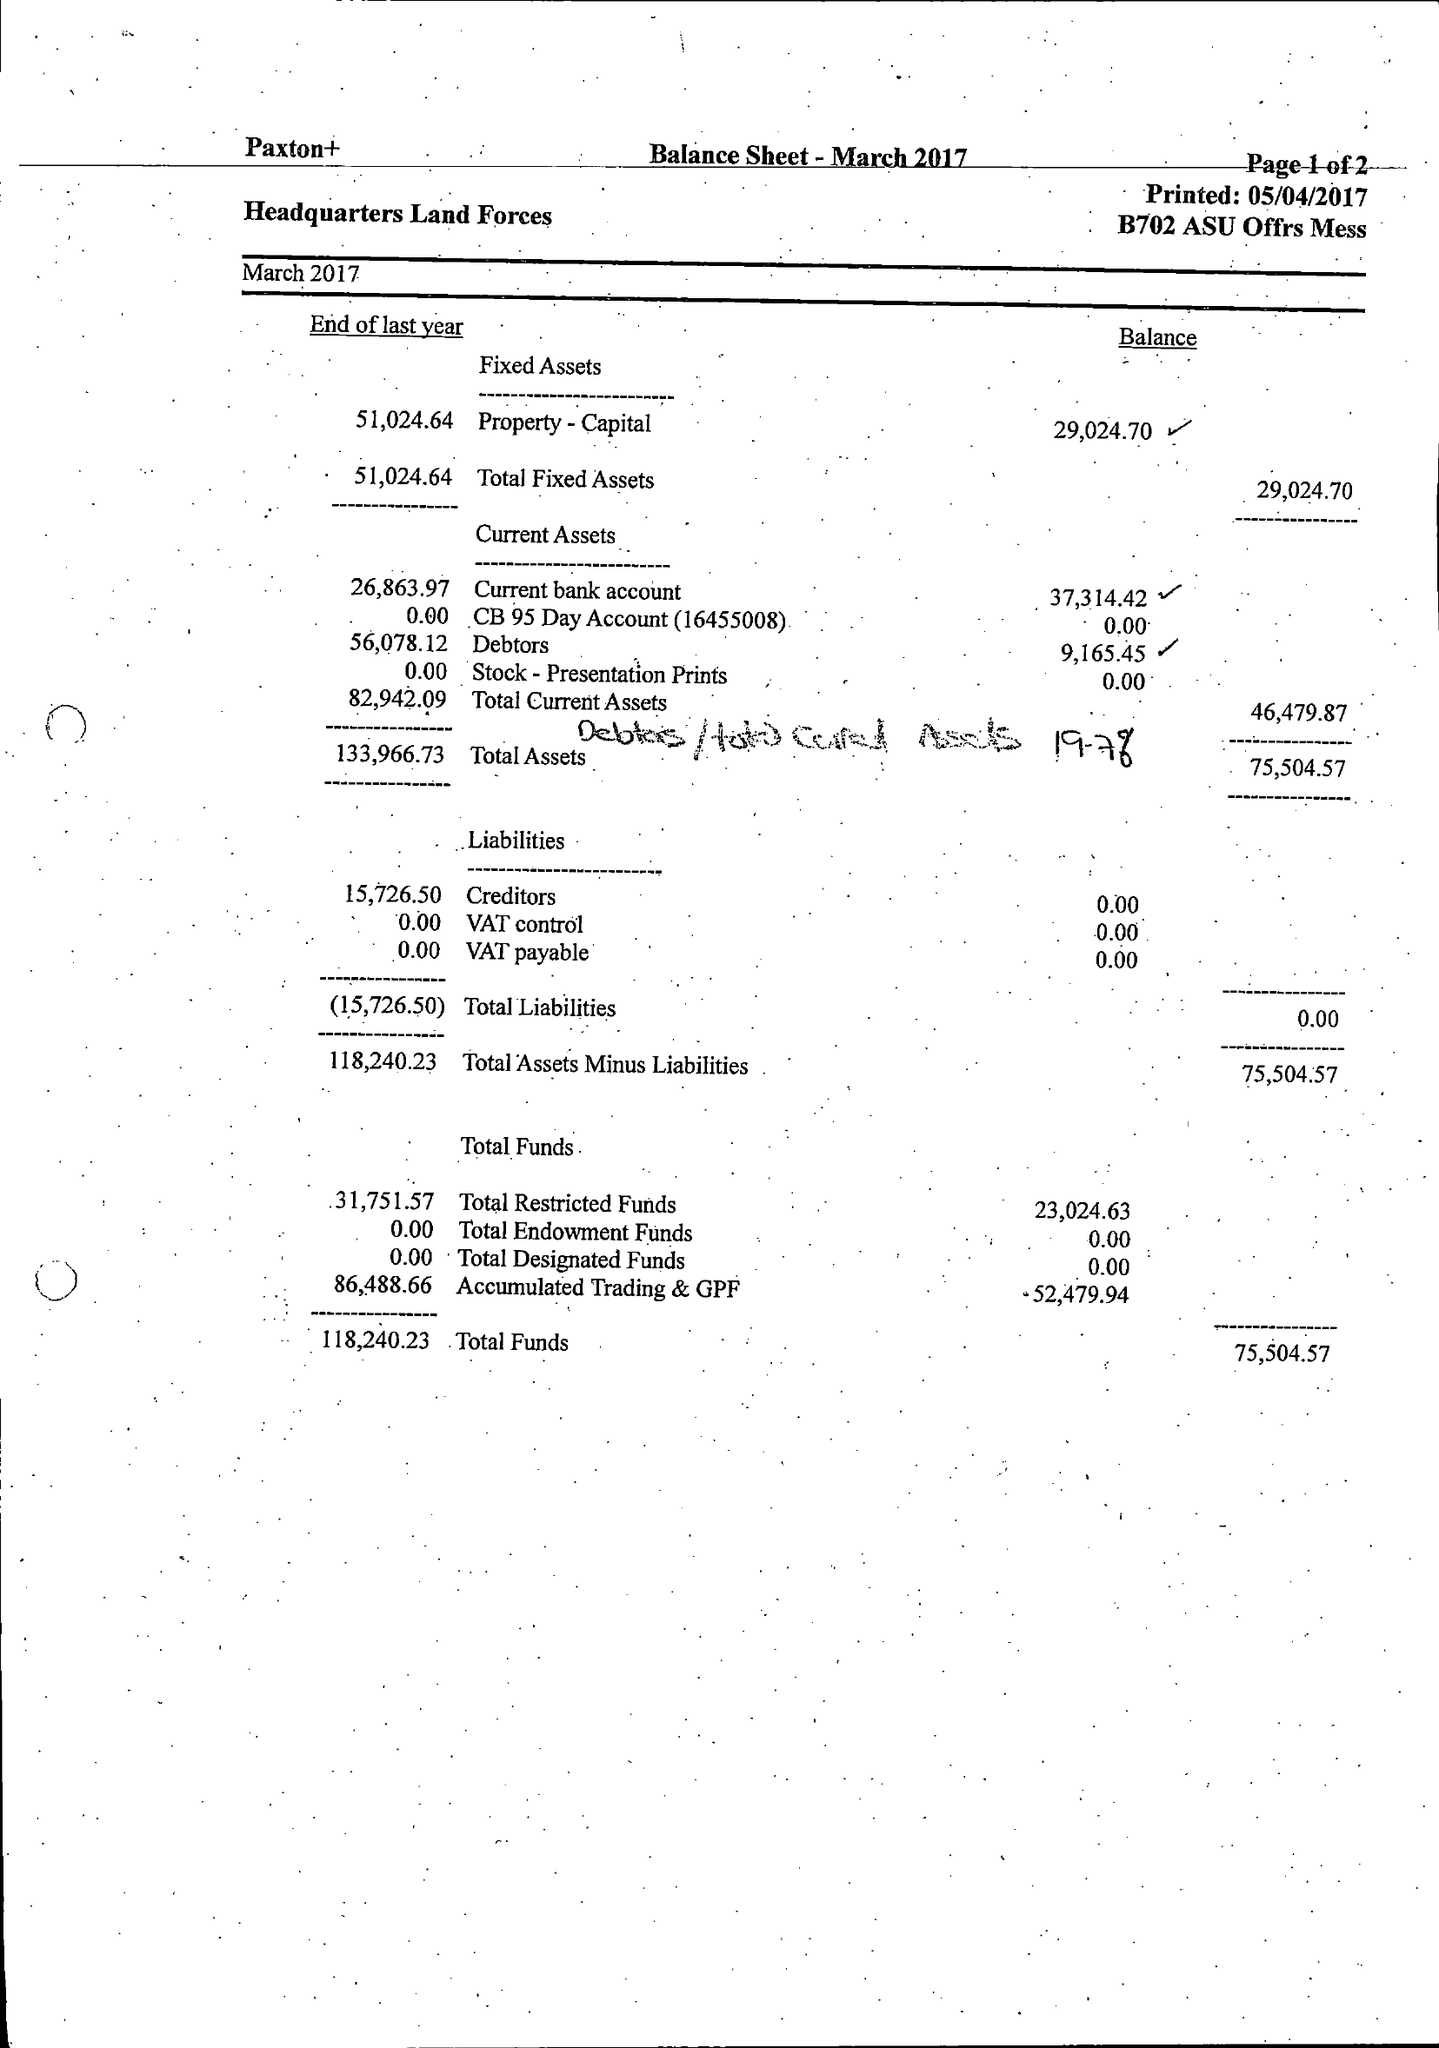What is the value for the charity_number?
Answer the question using a single word or phrase. 1150189 